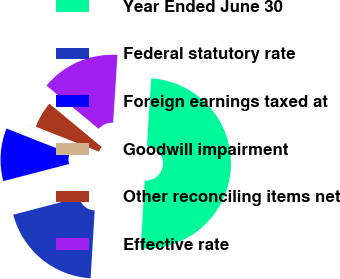Convert chart to OTSL. <chart><loc_0><loc_0><loc_500><loc_500><pie_chart><fcel>Year Ended June 30<fcel>Federal statutory rate<fcel>Foreign earnings taxed at<fcel>Goodwill impairment<fcel>Other reconciling items net<fcel>Effective rate<nl><fcel>49.95%<fcel>20.0%<fcel>10.01%<fcel>0.03%<fcel>5.02%<fcel>15.0%<nl></chart> 